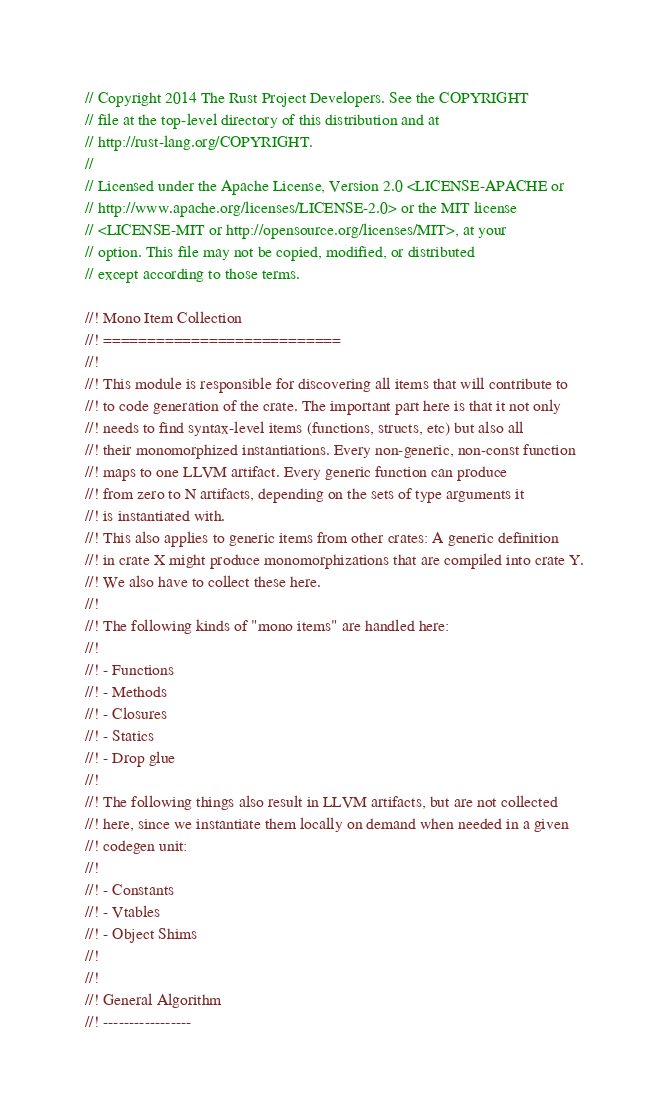<code> <loc_0><loc_0><loc_500><loc_500><_Rust_>// Copyright 2014 The Rust Project Developers. See the COPYRIGHT
// file at the top-level directory of this distribution and at
// http://rust-lang.org/COPYRIGHT.
//
// Licensed under the Apache License, Version 2.0 <LICENSE-APACHE or
// http://www.apache.org/licenses/LICENSE-2.0> or the MIT license
// <LICENSE-MIT or http://opensource.org/licenses/MIT>, at your
// option. This file may not be copied, modified, or distributed
// except according to those terms.

//! Mono Item Collection
//! ===========================
//!
//! This module is responsible for discovering all items that will contribute to
//! to code generation of the crate. The important part here is that it not only
//! needs to find syntax-level items (functions, structs, etc) but also all
//! their monomorphized instantiations. Every non-generic, non-const function
//! maps to one LLVM artifact. Every generic function can produce
//! from zero to N artifacts, depending on the sets of type arguments it
//! is instantiated with.
//! This also applies to generic items from other crates: A generic definition
//! in crate X might produce monomorphizations that are compiled into crate Y.
//! We also have to collect these here.
//!
//! The following kinds of "mono items" are handled here:
//!
//! - Functions
//! - Methods
//! - Closures
//! - Statics
//! - Drop glue
//!
//! The following things also result in LLVM artifacts, but are not collected
//! here, since we instantiate them locally on demand when needed in a given
//! codegen unit:
//!
//! - Constants
//! - Vtables
//! - Object Shims
//!
//!
//! General Algorithm
//! -----------------</code> 